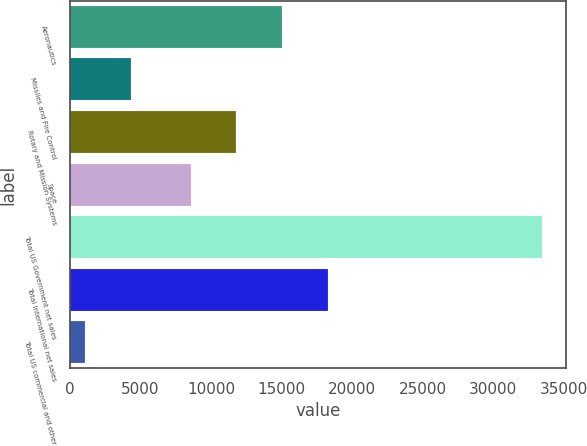<chart> <loc_0><loc_0><loc_500><loc_500><bar_chart><fcel>Aeronautics<fcel>Missiles and Fire Control<fcel>Rotary and Mission Systems<fcel>Space<fcel>Total US Government net sales<fcel>Total international net sales<fcel>Total US commercial and other<nl><fcel>15022<fcel>4314.5<fcel>11782.5<fcel>8543<fcel>33470<fcel>18261.5<fcel>1075<nl></chart> 